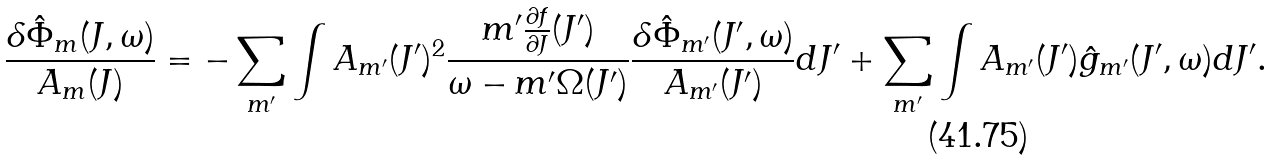<formula> <loc_0><loc_0><loc_500><loc_500>\frac { \delta \hat { \Phi } _ { m } ( J , \omega ) } { A _ { m } ( J ) } = - \sum _ { m ^ { \prime } } \int A _ { m ^ { \prime } } ( J ^ { \prime } ) ^ { 2 } \frac { m ^ { \prime } \frac { \partial f } { \partial J } ( J ^ { \prime } ) } { \omega - m ^ { \prime } \Omega ( J ^ { \prime } ) } \frac { \delta \hat { \Phi } _ { m ^ { \prime } } ( J ^ { \prime } , \omega ) } { A _ { m ^ { \prime } } ( J ^ { \prime } ) } d J ^ { \prime } + \sum _ { m ^ { \prime } } \int A _ { m ^ { \prime } } ( J ^ { \prime } ) \hat { g } _ { m ^ { \prime } } ( J ^ { \prime } , \omega ) d J ^ { \prime } .</formula> 